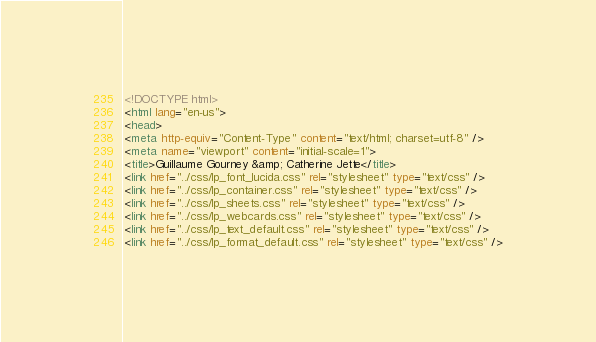<code> <loc_0><loc_0><loc_500><loc_500><_HTML_><!DOCTYPE html>
<html lang="en-us">
<head>
<meta http-equiv="Content-Type" content="text/html; charset=utf-8" />
<meta name="viewport" content="initial-scale=1">
<title>Guillaume Gourney &amp; Catherine Jette</title>
<link href="../css/lp_font_lucida.css" rel="stylesheet" type="text/css" />
<link href="../css/lp_container.css" rel="stylesheet" type="text/css" />
<link href="../css/lp_sheets.css" rel="stylesheet" type="text/css" />
<link href="../css/lp_webcards.css" rel="stylesheet" type="text/css" />
<link href="../css/lp_text_default.css" rel="stylesheet" type="text/css" />
<link href="../css/lp_format_default.css" rel="stylesheet" type="text/css" /></code> 